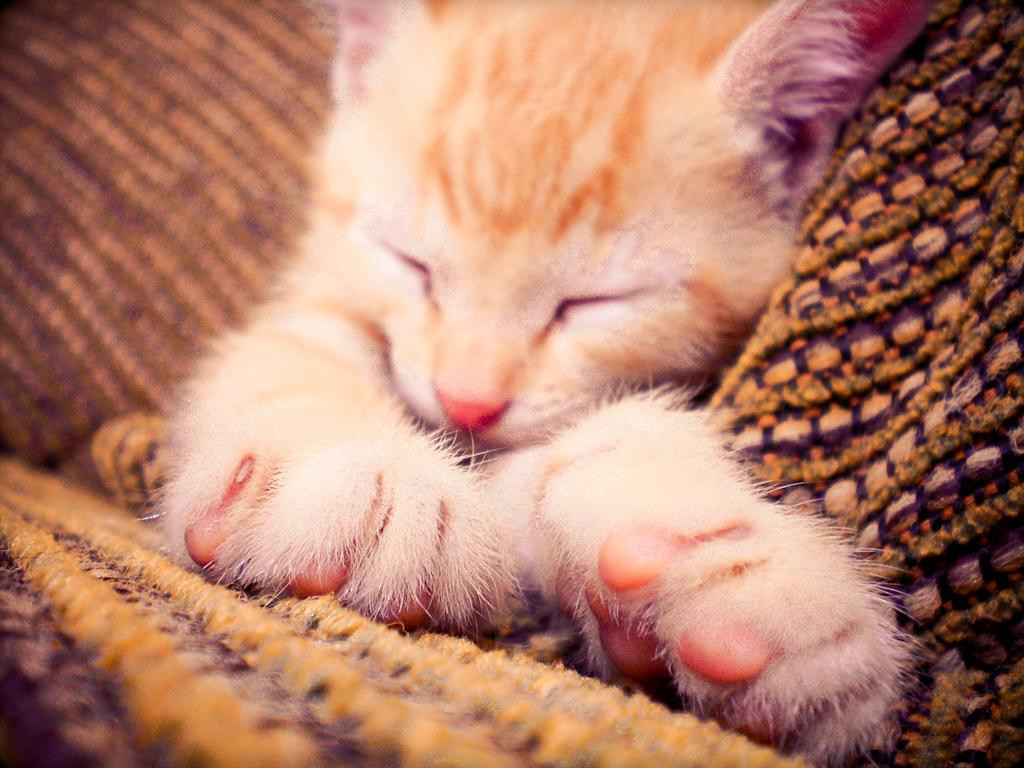What type of animal is in the image? There is a cat in the image. What is the cat doing in the image? The cat is sleeping. Where is the cat located in the image? The cat is on a mat. What government policy is being discussed in the image? There is no discussion of government policy in the image; it features a sleeping cat on a mat. 